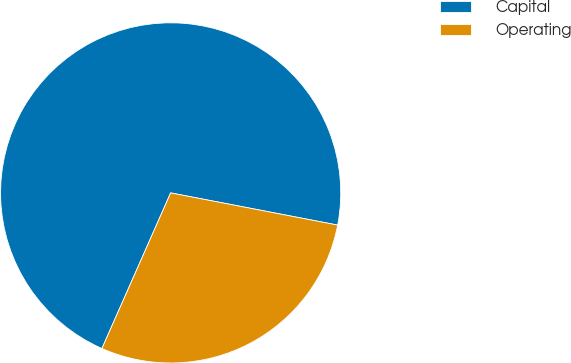Convert chart to OTSL. <chart><loc_0><loc_0><loc_500><loc_500><pie_chart><fcel>Capital<fcel>Operating<nl><fcel>71.41%<fcel>28.59%<nl></chart> 